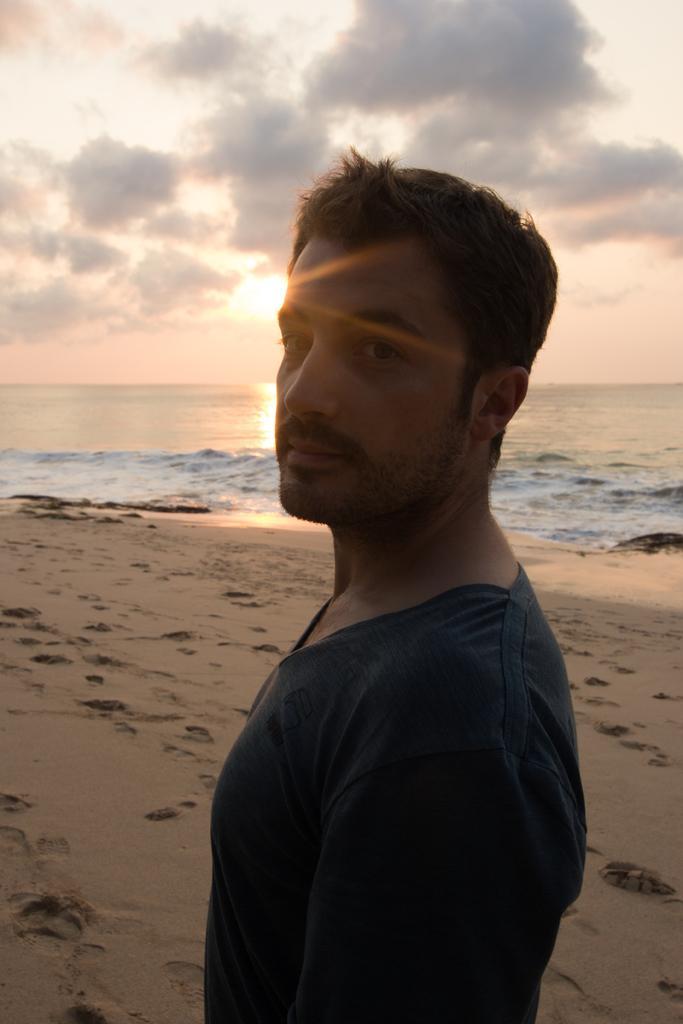How would you summarize this image in a sentence or two? In this picture we can see a man is standing in the front, at the bottom there is soil, in the background we can see water, there is the sky and clouds at the top of the picture. 